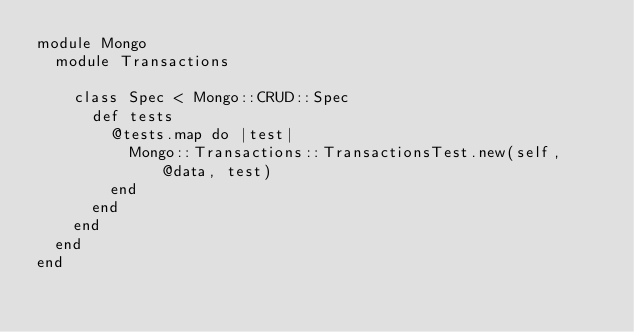<code> <loc_0><loc_0><loc_500><loc_500><_Ruby_>module Mongo
  module Transactions

    class Spec < Mongo::CRUD::Spec
      def tests
        @tests.map do |test|
          Mongo::Transactions::TransactionsTest.new(self, @data, test)
        end
      end
    end
  end
end
</code> 